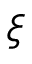<formula> <loc_0><loc_0><loc_500><loc_500>\xi</formula> 